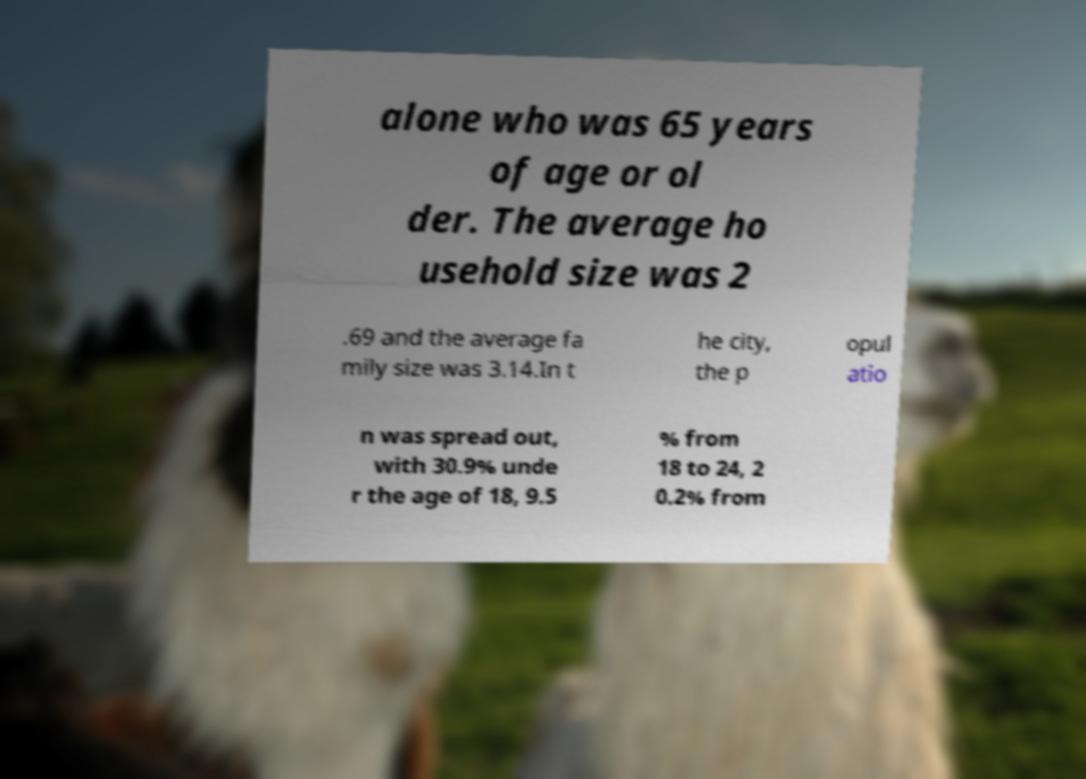Could you extract and type out the text from this image? alone who was 65 years of age or ol der. The average ho usehold size was 2 .69 and the average fa mily size was 3.14.In t he city, the p opul atio n was spread out, with 30.9% unde r the age of 18, 9.5 % from 18 to 24, 2 0.2% from 